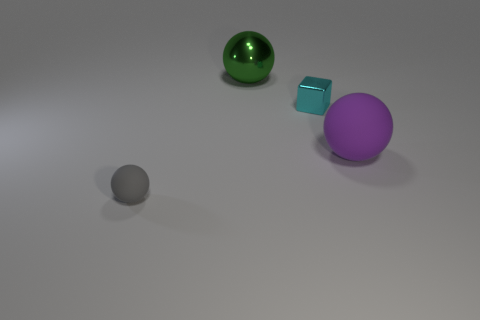Does the sphere behind the large purple thing have the same material as the small thing that is on the left side of the small cyan object?
Make the answer very short. No. There is a big sphere behind the shiny cube that is behind the tiny thing in front of the cyan metallic thing; what color is it?
Ensure brevity in your answer.  Green. How many other objects are the same shape as the cyan shiny thing?
Offer a terse response. 0. Is the metal block the same color as the large metallic sphere?
Offer a very short reply. No. What number of things are large gray cylinders or spheres behind the gray matte thing?
Your response must be concise. 2. Are there any other shiny cubes of the same size as the block?
Offer a very short reply. No. Do the large purple ball and the small block have the same material?
Your answer should be very brief. No. How many things are either brown metal blocks or green balls?
Ensure brevity in your answer.  1. How big is the gray matte ball?
Your response must be concise. Small. Are there fewer large rubber objects than small green matte things?
Give a very brief answer. No. 